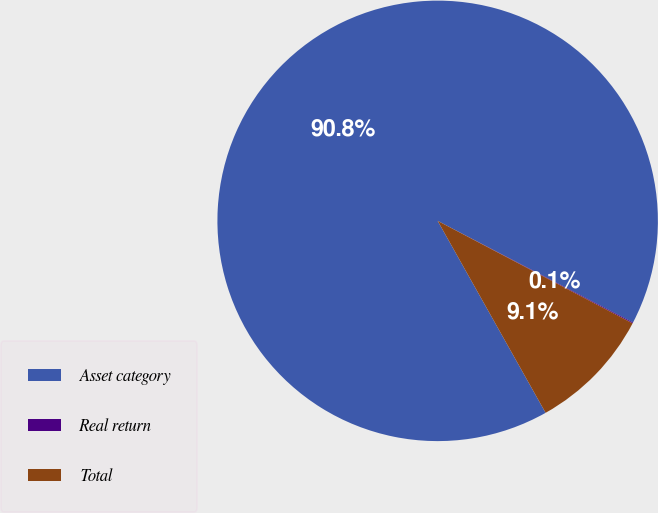Convert chart. <chart><loc_0><loc_0><loc_500><loc_500><pie_chart><fcel>Asset category<fcel>Real return<fcel>Total<nl><fcel>90.78%<fcel>0.07%<fcel>9.14%<nl></chart> 